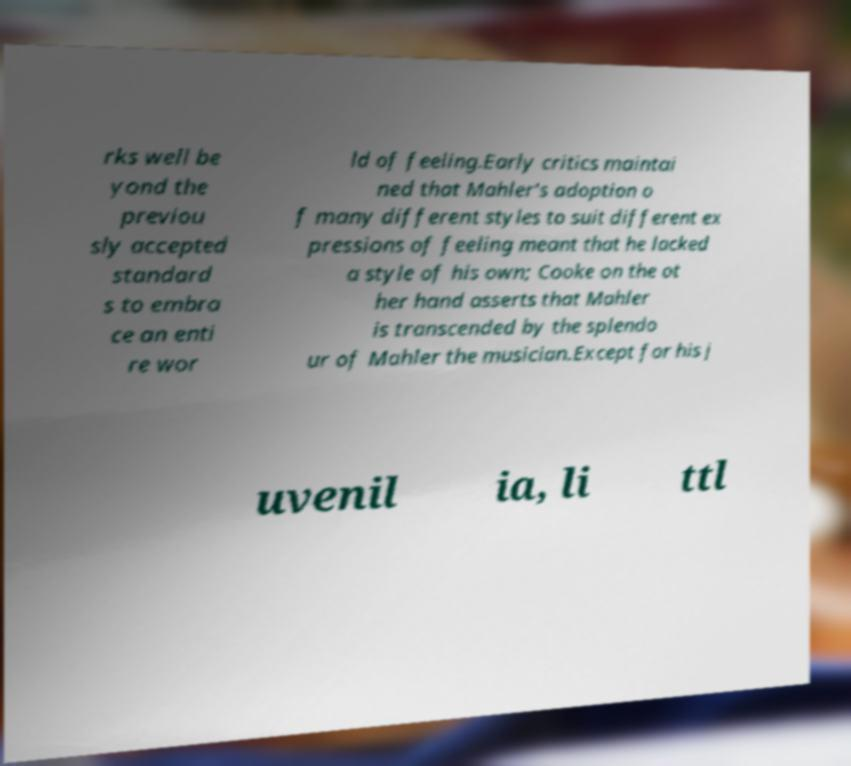Can you read and provide the text displayed in the image?This photo seems to have some interesting text. Can you extract and type it out for me? rks well be yond the previou sly accepted standard s to embra ce an enti re wor ld of feeling.Early critics maintai ned that Mahler's adoption o f many different styles to suit different ex pressions of feeling meant that he lacked a style of his own; Cooke on the ot her hand asserts that Mahler is transcended by the splendo ur of Mahler the musician.Except for his j uvenil ia, li ttl 